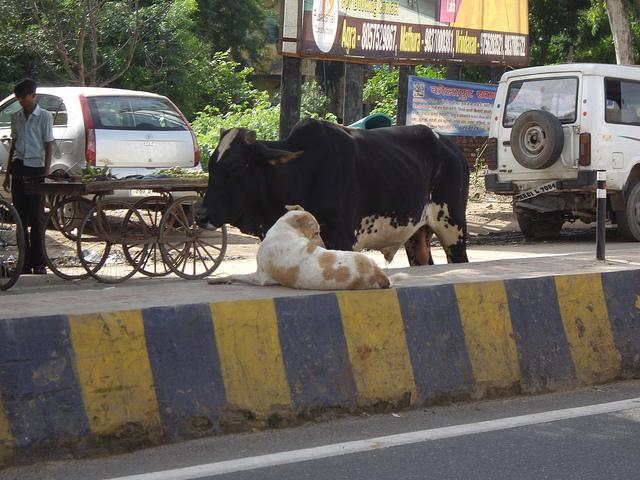What is known as the best cut of meat from the largest animal? filet mignon 